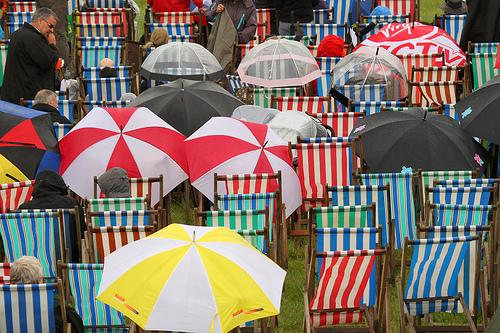Count the total number of umbrellas in the image. There are 12 umbrellas in total in the image. What are the common objects that people are interacting with in this scene? People are interacting with beach chairs, umbrellas, and each other. Do any of the umbrellas in the image have advertisements? Yes, there is one umbrella with advertisements, the yellow and white one. Mention two types of umbrellas that stand out in the scene. A yellow and white umbrella and a classic black umbrella are prominent in the scene. Identify the distinct beach chair designs and their colors in the image. Blue and white striped chair, red and white striped chair, and green and white striped chair. What is the primary seating arrangement in the image? Seating for an event with colorful striped seats, including green, blue, and red. Describe the attire of the man standing in the background and the person wearing a hooded jacket. The man standing is wearing a black jacket, and the person wearing a hooded jacket has a black hood. How many people can be seen sitting in beach chairs, and what is their age group? There are two older people sitting in beach chairs. What types of umbrellas can be seen in the crowd? There are two clear umbrellas, a yellow and white umbrella, a pink and clear umbrella, a red and white umbrella, and a see-through grey umbrella. Provide a brief overview of the scene in the image. The image features a colorful seating arrangement for an event with a mix of people, beach chairs, and various styles and colors of umbrellas. 